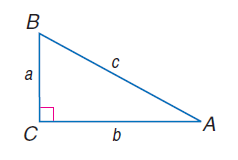Answer the mathemtical geometry problem and directly provide the correct option letter.
Question: a = 14, b = 48, and c = 50, find \tan A.
Choices: A: 0.17 B: 0.19 C: 0.29 D: 0.50 C 